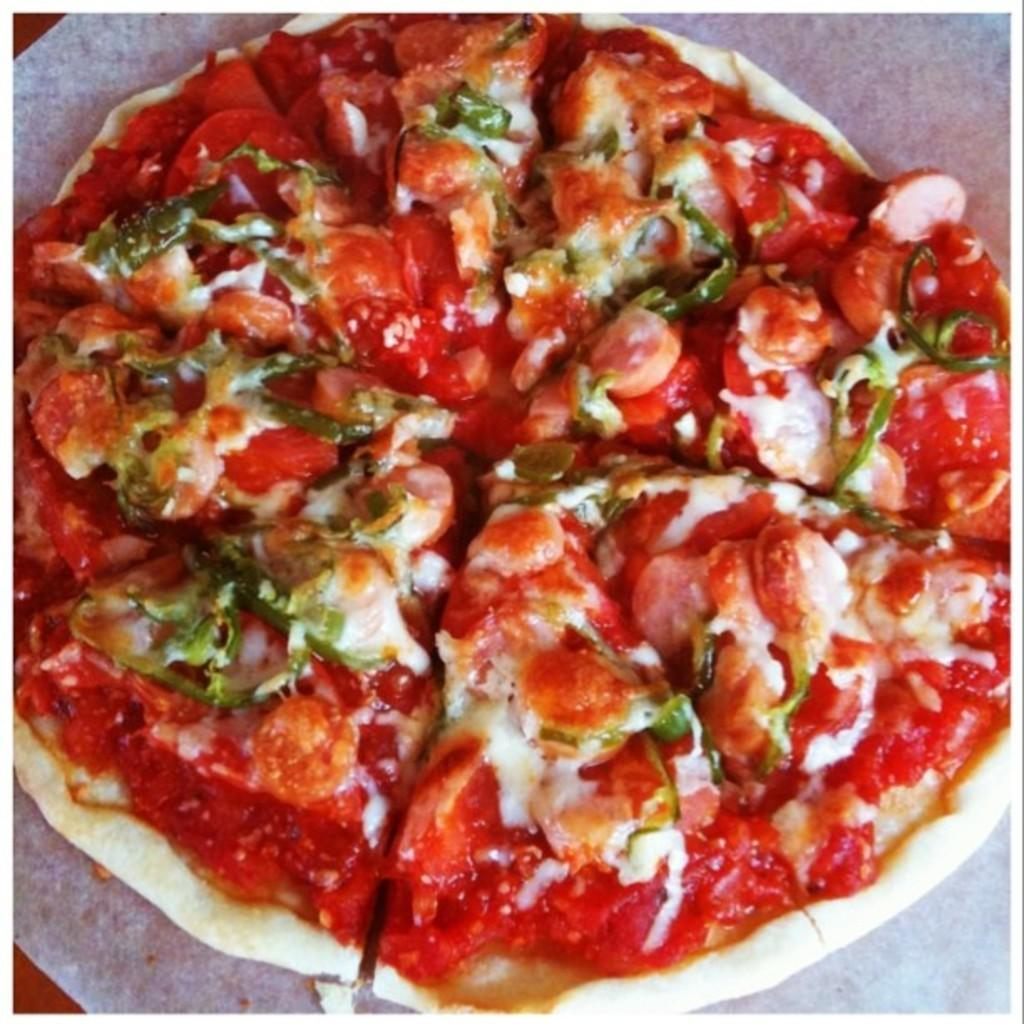What type of food is on the plate in the image? There is a pizza on a white plate in the image. Can you describe the objects in the corners of the image? There are two objects, one in the top left corner and another in the bottom left corner of the image. How many scarecrows are present on the island in the image? There is no island or scarecrow present in the image. 